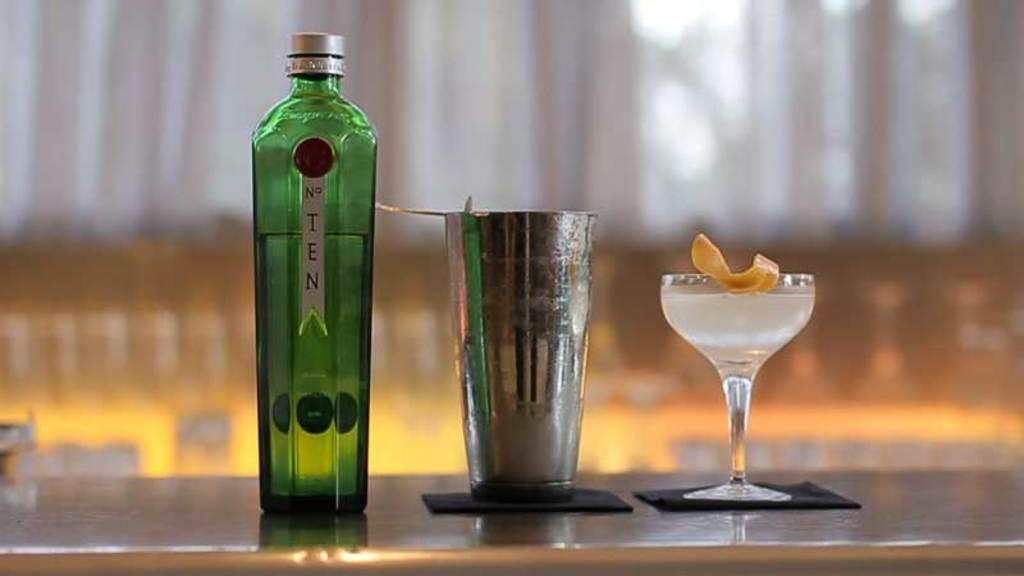<image>
Present a compact description of the photo's key features. A bottle of number Ten next to a mixing cup and wine glass. 